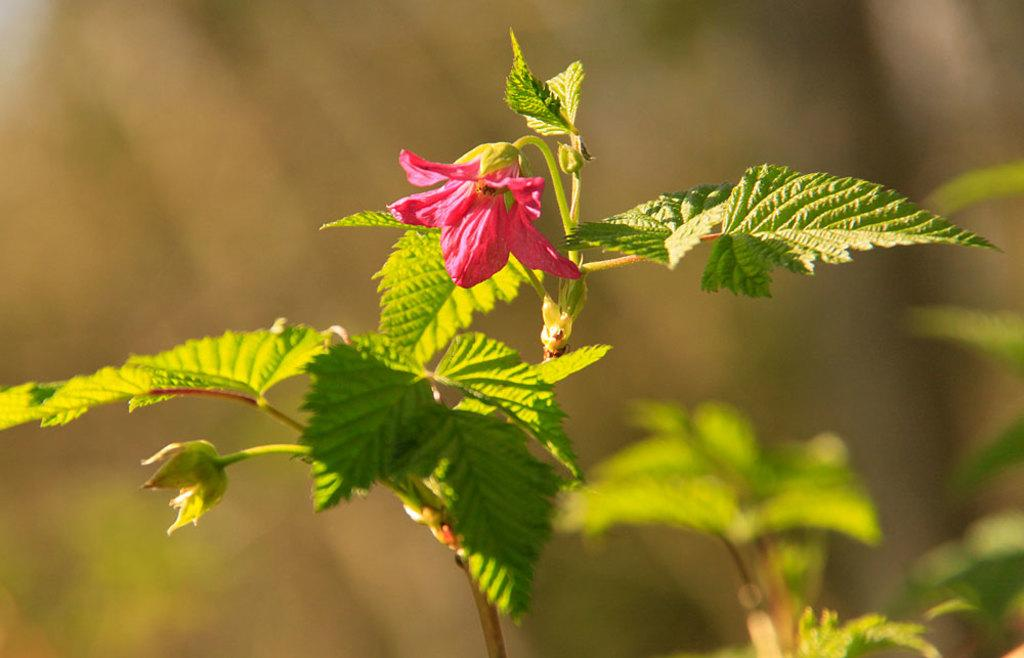What is the main subject of the image? There is a flower in the image. What color is the flower? The flower is pink. Are there any other parts of the flower visible in the image? Yes, there are green leaves associated with the flower. How would you describe the background of the image? The background of the image is blurred. Can you see a bee moving around the flower in the image? There is no bee present in the image, and therefore no movement can be observed. Is the flower located on an island in the image? There is no indication of an island in the image; it only features a pink flower with green leaves and a blurred background. 